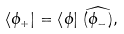<formula> <loc_0><loc_0><loc_500><loc_500>\left < \phi _ { + } \right | = \left < \phi \right | \, \widehat { ( \phi _ { - } ) } ,</formula> 